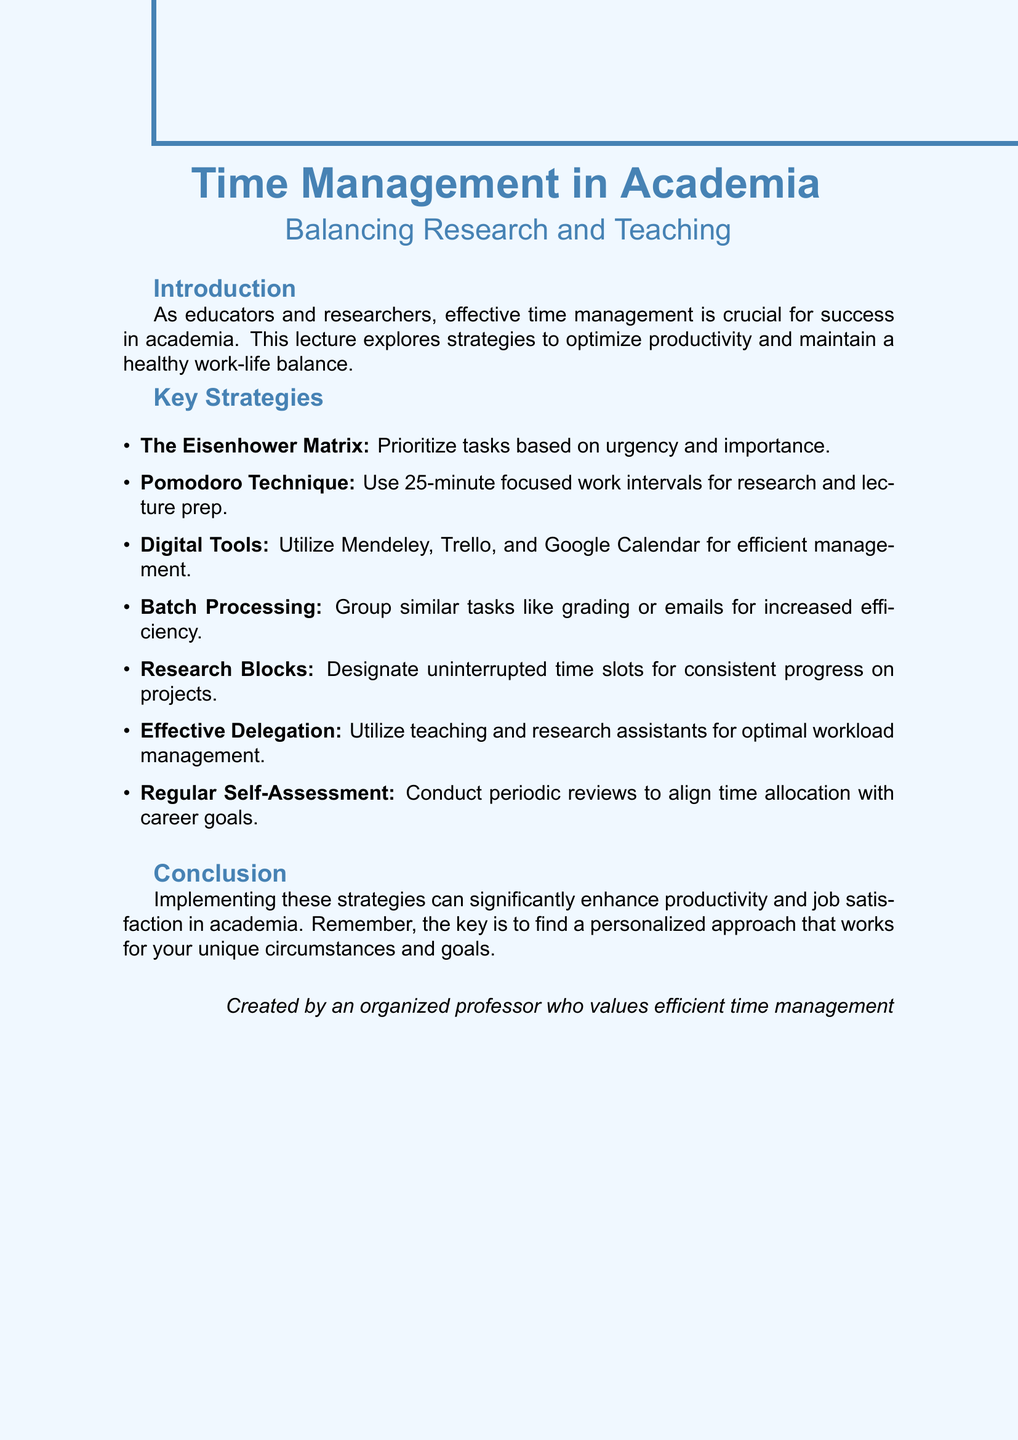What is the title of the document? The title is mentioned at the beginning of the document and provides the main subject of the lecture.
Answer: Time Management in Academia: Balancing Research and Teaching What is the primary purpose of the lecture? The introduction clearly states the aim of the lecture regarding time management.
Answer: Optimize productivity and maintain a healthy work-life balance How many key strategies are outlined in the document? The document lists a total of strategies in the key section.
Answer: Seven What is one example of a digital tool mentioned? The document provides examples of digital tools under the relevant key point.
Answer: Mendeley What technique uses focused 25-minute work intervals? This information is outlined in a key strategy section of the document.
Answer: Pomodoro Technique What is the main benefit of the Eisenhower Matrix? The description explains how this tool helps academics manage their tasks effectively.
Answer: Focus on high-impact activities What should be conducted to ensure alignment with career goals? The document highlights the importance of this practice in maintaining effective time management.
Answer: Regular Self-Assessment What is the final takeaway from the lecture? The conclusion provides a succinct summary of the implemented strategies' outcomes.
Answer: Enhance productivity and job satisfaction 